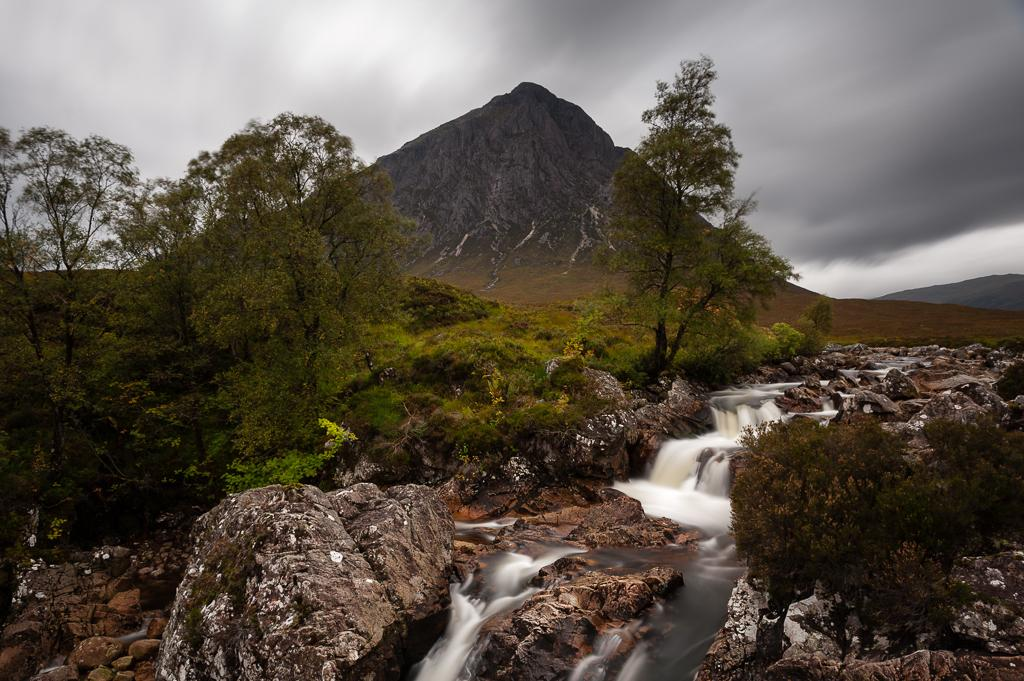What type of natural elements can be seen in the image? Rocks, water, trees, and mountains are visible in the image. What is the condition of the sky in the image? The sky is visible in the background of the image, and clouds are present. Can you tell me how many geese are attacking the trees in the image? There are no geese present in the image, and therefore no such attack can be observed. 